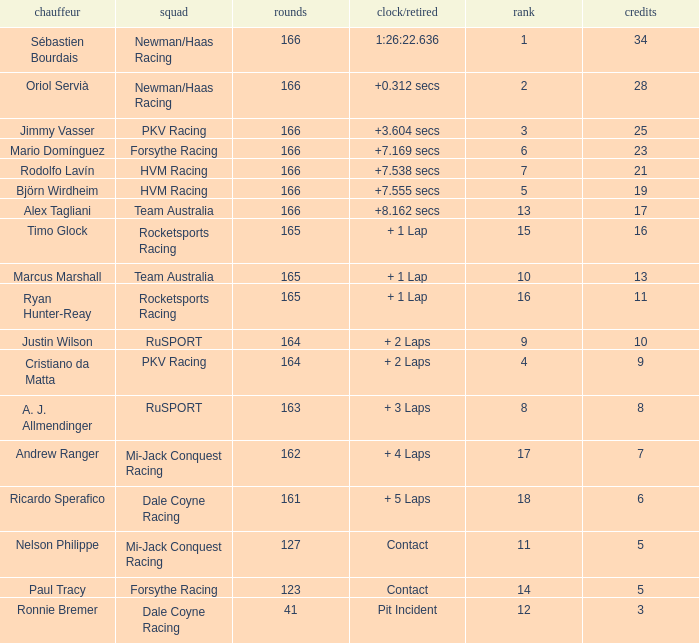Driver Ricardo Sperafico has what as his average laps? 161.0. 